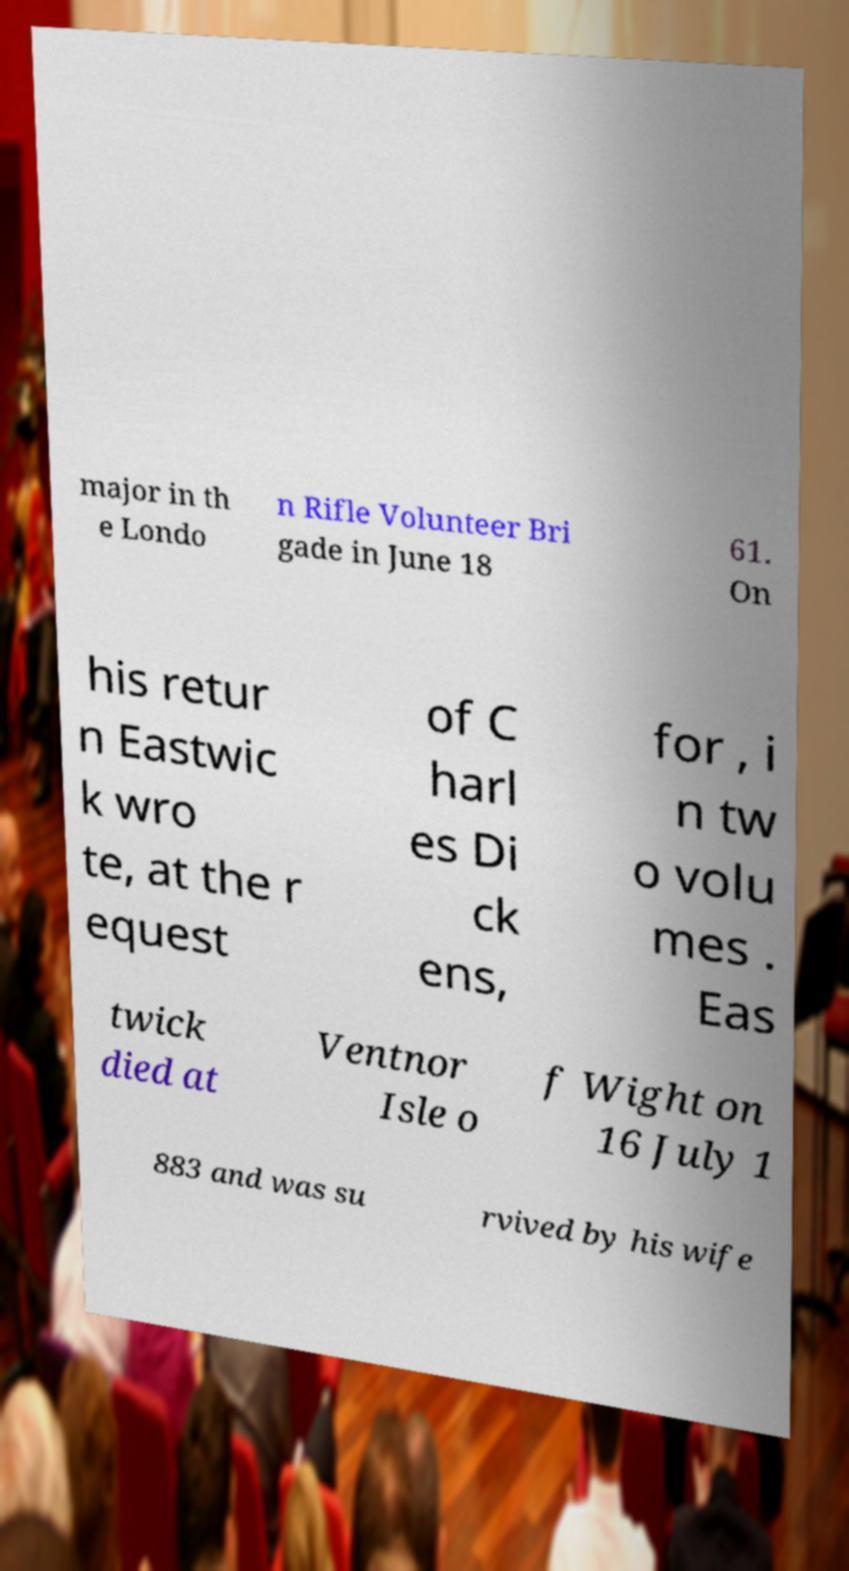Can you accurately transcribe the text from the provided image for me? major in th e Londo n Rifle Volunteer Bri gade in June 18 61. On his retur n Eastwic k wro te, at the r equest of C harl es Di ck ens, for , i n tw o volu mes . Eas twick died at Ventnor Isle o f Wight on 16 July 1 883 and was su rvived by his wife 